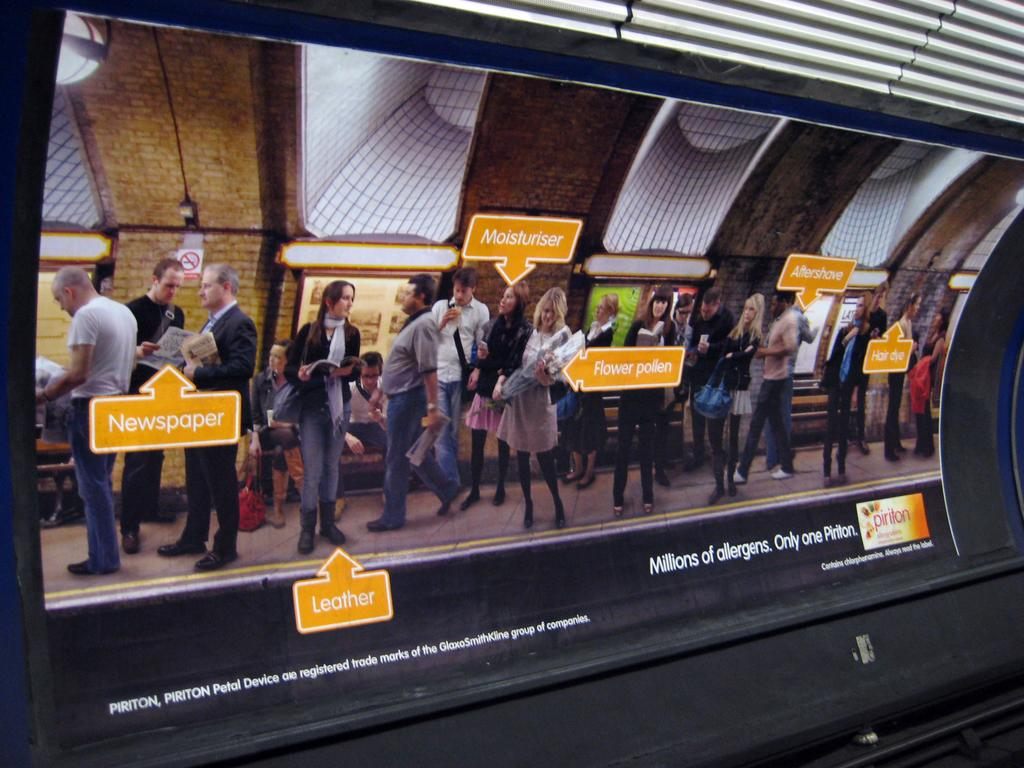What is the main object in the image? There is a screen in the image. What can be seen in front of the screen? There are many people standing in front of the screen. What is visible at the top of the image? There is a wall visible at the top of the image. What type of location might this image depict? The image appears to depict a movie theater. Can you see any volcanoes erupting in the image? No, there are no volcanoes or eruptions present in the image. What type of produce is being sold in the image? There is no produce being sold in the image; it depicts a movie theater with a screen and people standing in front of it. 